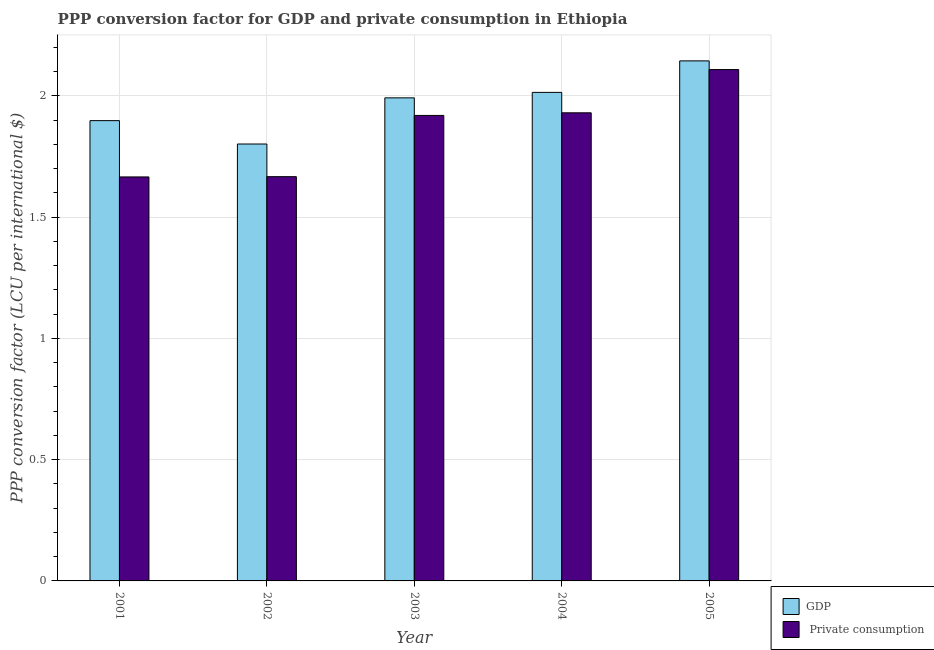How many different coloured bars are there?
Ensure brevity in your answer.  2. How many groups of bars are there?
Your response must be concise. 5. Are the number of bars per tick equal to the number of legend labels?
Ensure brevity in your answer.  Yes. Are the number of bars on each tick of the X-axis equal?
Make the answer very short. Yes. In how many cases, is the number of bars for a given year not equal to the number of legend labels?
Your response must be concise. 0. What is the ppp conversion factor for gdp in 2003?
Your response must be concise. 1.99. Across all years, what is the maximum ppp conversion factor for private consumption?
Provide a short and direct response. 2.11. Across all years, what is the minimum ppp conversion factor for gdp?
Provide a short and direct response. 1.8. In which year was the ppp conversion factor for private consumption maximum?
Your answer should be very brief. 2005. What is the total ppp conversion factor for gdp in the graph?
Provide a short and direct response. 9.85. What is the difference between the ppp conversion factor for gdp in 2003 and that in 2004?
Make the answer very short. -0.02. What is the difference between the ppp conversion factor for gdp in 2003 and the ppp conversion factor for private consumption in 2004?
Your answer should be compact. -0.02. What is the average ppp conversion factor for gdp per year?
Provide a succinct answer. 1.97. In the year 2002, what is the difference between the ppp conversion factor for gdp and ppp conversion factor for private consumption?
Offer a very short reply. 0. What is the ratio of the ppp conversion factor for private consumption in 2002 to that in 2005?
Your response must be concise. 0.79. What is the difference between the highest and the second highest ppp conversion factor for gdp?
Your answer should be very brief. 0.13. What is the difference between the highest and the lowest ppp conversion factor for gdp?
Offer a very short reply. 0.34. In how many years, is the ppp conversion factor for gdp greater than the average ppp conversion factor for gdp taken over all years?
Your answer should be very brief. 3. Is the sum of the ppp conversion factor for private consumption in 2004 and 2005 greater than the maximum ppp conversion factor for gdp across all years?
Offer a terse response. Yes. What does the 1st bar from the left in 2005 represents?
Keep it short and to the point. GDP. What does the 1st bar from the right in 2002 represents?
Provide a short and direct response.  Private consumption. Are all the bars in the graph horizontal?
Provide a short and direct response. No. What is the difference between two consecutive major ticks on the Y-axis?
Keep it short and to the point. 0.5. Does the graph contain any zero values?
Keep it short and to the point. No. How many legend labels are there?
Your answer should be very brief. 2. How are the legend labels stacked?
Make the answer very short. Vertical. What is the title of the graph?
Make the answer very short. PPP conversion factor for GDP and private consumption in Ethiopia. What is the label or title of the X-axis?
Provide a succinct answer. Year. What is the label or title of the Y-axis?
Your answer should be very brief. PPP conversion factor (LCU per international $). What is the PPP conversion factor (LCU per international $) in GDP in 2001?
Your answer should be compact. 1.9. What is the PPP conversion factor (LCU per international $) of  Private consumption in 2001?
Provide a succinct answer. 1.67. What is the PPP conversion factor (LCU per international $) in GDP in 2002?
Give a very brief answer. 1.8. What is the PPP conversion factor (LCU per international $) in  Private consumption in 2002?
Provide a succinct answer. 1.67. What is the PPP conversion factor (LCU per international $) in GDP in 2003?
Give a very brief answer. 1.99. What is the PPP conversion factor (LCU per international $) of  Private consumption in 2003?
Provide a short and direct response. 1.92. What is the PPP conversion factor (LCU per international $) in GDP in 2004?
Provide a short and direct response. 2.01. What is the PPP conversion factor (LCU per international $) in  Private consumption in 2004?
Offer a very short reply. 1.93. What is the PPP conversion factor (LCU per international $) in GDP in 2005?
Offer a very short reply. 2.14. What is the PPP conversion factor (LCU per international $) of  Private consumption in 2005?
Provide a short and direct response. 2.11. Across all years, what is the maximum PPP conversion factor (LCU per international $) of GDP?
Give a very brief answer. 2.14. Across all years, what is the maximum PPP conversion factor (LCU per international $) of  Private consumption?
Ensure brevity in your answer.  2.11. Across all years, what is the minimum PPP conversion factor (LCU per international $) in GDP?
Offer a terse response. 1.8. Across all years, what is the minimum PPP conversion factor (LCU per international $) of  Private consumption?
Ensure brevity in your answer.  1.67. What is the total PPP conversion factor (LCU per international $) in GDP in the graph?
Give a very brief answer. 9.85. What is the total PPP conversion factor (LCU per international $) of  Private consumption in the graph?
Provide a short and direct response. 9.29. What is the difference between the PPP conversion factor (LCU per international $) in GDP in 2001 and that in 2002?
Provide a succinct answer. 0.1. What is the difference between the PPP conversion factor (LCU per international $) of  Private consumption in 2001 and that in 2002?
Keep it short and to the point. -0. What is the difference between the PPP conversion factor (LCU per international $) in GDP in 2001 and that in 2003?
Make the answer very short. -0.09. What is the difference between the PPP conversion factor (LCU per international $) in  Private consumption in 2001 and that in 2003?
Give a very brief answer. -0.25. What is the difference between the PPP conversion factor (LCU per international $) of GDP in 2001 and that in 2004?
Your answer should be compact. -0.12. What is the difference between the PPP conversion factor (LCU per international $) in  Private consumption in 2001 and that in 2004?
Provide a succinct answer. -0.26. What is the difference between the PPP conversion factor (LCU per international $) in GDP in 2001 and that in 2005?
Your response must be concise. -0.25. What is the difference between the PPP conversion factor (LCU per international $) of  Private consumption in 2001 and that in 2005?
Your response must be concise. -0.44. What is the difference between the PPP conversion factor (LCU per international $) of GDP in 2002 and that in 2003?
Keep it short and to the point. -0.19. What is the difference between the PPP conversion factor (LCU per international $) of  Private consumption in 2002 and that in 2003?
Offer a terse response. -0.25. What is the difference between the PPP conversion factor (LCU per international $) in GDP in 2002 and that in 2004?
Offer a terse response. -0.21. What is the difference between the PPP conversion factor (LCU per international $) of  Private consumption in 2002 and that in 2004?
Your answer should be compact. -0.26. What is the difference between the PPP conversion factor (LCU per international $) in GDP in 2002 and that in 2005?
Offer a terse response. -0.34. What is the difference between the PPP conversion factor (LCU per international $) of  Private consumption in 2002 and that in 2005?
Offer a very short reply. -0.44. What is the difference between the PPP conversion factor (LCU per international $) in GDP in 2003 and that in 2004?
Make the answer very short. -0.02. What is the difference between the PPP conversion factor (LCU per international $) of  Private consumption in 2003 and that in 2004?
Your answer should be very brief. -0.01. What is the difference between the PPP conversion factor (LCU per international $) of GDP in 2003 and that in 2005?
Your response must be concise. -0.15. What is the difference between the PPP conversion factor (LCU per international $) in  Private consumption in 2003 and that in 2005?
Your answer should be compact. -0.19. What is the difference between the PPP conversion factor (LCU per international $) in GDP in 2004 and that in 2005?
Your response must be concise. -0.13. What is the difference between the PPP conversion factor (LCU per international $) of  Private consumption in 2004 and that in 2005?
Give a very brief answer. -0.18. What is the difference between the PPP conversion factor (LCU per international $) of GDP in 2001 and the PPP conversion factor (LCU per international $) of  Private consumption in 2002?
Offer a very short reply. 0.23. What is the difference between the PPP conversion factor (LCU per international $) in GDP in 2001 and the PPP conversion factor (LCU per international $) in  Private consumption in 2003?
Your answer should be compact. -0.02. What is the difference between the PPP conversion factor (LCU per international $) of GDP in 2001 and the PPP conversion factor (LCU per international $) of  Private consumption in 2004?
Provide a succinct answer. -0.03. What is the difference between the PPP conversion factor (LCU per international $) in GDP in 2001 and the PPP conversion factor (LCU per international $) in  Private consumption in 2005?
Provide a succinct answer. -0.21. What is the difference between the PPP conversion factor (LCU per international $) in GDP in 2002 and the PPP conversion factor (LCU per international $) in  Private consumption in 2003?
Offer a very short reply. -0.12. What is the difference between the PPP conversion factor (LCU per international $) of GDP in 2002 and the PPP conversion factor (LCU per international $) of  Private consumption in 2004?
Your answer should be compact. -0.13. What is the difference between the PPP conversion factor (LCU per international $) of GDP in 2002 and the PPP conversion factor (LCU per international $) of  Private consumption in 2005?
Offer a terse response. -0.31. What is the difference between the PPP conversion factor (LCU per international $) in GDP in 2003 and the PPP conversion factor (LCU per international $) in  Private consumption in 2004?
Your response must be concise. 0.06. What is the difference between the PPP conversion factor (LCU per international $) of GDP in 2003 and the PPP conversion factor (LCU per international $) of  Private consumption in 2005?
Ensure brevity in your answer.  -0.12. What is the difference between the PPP conversion factor (LCU per international $) of GDP in 2004 and the PPP conversion factor (LCU per international $) of  Private consumption in 2005?
Provide a succinct answer. -0.09. What is the average PPP conversion factor (LCU per international $) of GDP per year?
Offer a terse response. 1.97. What is the average PPP conversion factor (LCU per international $) of  Private consumption per year?
Offer a very short reply. 1.86. In the year 2001, what is the difference between the PPP conversion factor (LCU per international $) in GDP and PPP conversion factor (LCU per international $) in  Private consumption?
Provide a short and direct response. 0.23. In the year 2002, what is the difference between the PPP conversion factor (LCU per international $) of GDP and PPP conversion factor (LCU per international $) of  Private consumption?
Provide a succinct answer. 0.13. In the year 2003, what is the difference between the PPP conversion factor (LCU per international $) in GDP and PPP conversion factor (LCU per international $) in  Private consumption?
Give a very brief answer. 0.07. In the year 2004, what is the difference between the PPP conversion factor (LCU per international $) in GDP and PPP conversion factor (LCU per international $) in  Private consumption?
Your response must be concise. 0.08. In the year 2005, what is the difference between the PPP conversion factor (LCU per international $) in GDP and PPP conversion factor (LCU per international $) in  Private consumption?
Offer a very short reply. 0.04. What is the ratio of the PPP conversion factor (LCU per international $) in GDP in 2001 to that in 2002?
Offer a very short reply. 1.05. What is the ratio of the PPP conversion factor (LCU per international $) of GDP in 2001 to that in 2003?
Your response must be concise. 0.95. What is the ratio of the PPP conversion factor (LCU per international $) in  Private consumption in 2001 to that in 2003?
Provide a succinct answer. 0.87. What is the ratio of the PPP conversion factor (LCU per international $) of GDP in 2001 to that in 2004?
Provide a short and direct response. 0.94. What is the ratio of the PPP conversion factor (LCU per international $) in  Private consumption in 2001 to that in 2004?
Give a very brief answer. 0.86. What is the ratio of the PPP conversion factor (LCU per international $) of GDP in 2001 to that in 2005?
Keep it short and to the point. 0.89. What is the ratio of the PPP conversion factor (LCU per international $) in  Private consumption in 2001 to that in 2005?
Provide a short and direct response. 0.79. What is the ratio of the PPP conversion factor (LCU per international $) of GDP in 2002 to that in 2003?
Provide a short and direct response. 0.9. What is the ratio of the PPP conversion factor (LCU per international $) of  Private consumption in 2002 to that in 2003?
Ensure brevity in your answer.  0.87. What is the ratio of the PPP conversion factor (LCU per international $) in GDP in 2002 to that in 2004?
Your response must be concise. 0.89. What is the ratio of the PPP conversion factor (LCU per international $) of  Private consumption in 2002 to that in 2004?
Make the answer very short. 0.86. What is the ratio of the PPP conversion factor (LCU per international $) of GDP in 2002 to that in 2005?
Your response must be concise. 0.84. What is the ratio of the PPP conversion factor (LCU per international $) of  Private consumption in 2002 to that in 2005?
Give a very brief answer. 0.79. What is the ratio of the PPP conversion factor (LCU per international $) of GDP in 2003 to that in 2005?
Your answer should be very brief. 0.93. What is the ratio of the PPP conversion factor (LCU per international $) of  Private consumption in 2003 to that in 2005?
Keep it short and to the point. 0.91. What is the ratio of the PPP conversion factor (LCU per international $) of GDP in 2004 to that in 2005?
Offer a very short reply. 0.94. What is the ratio of the PPP conversion factor (LCU per international $) in  Private consumption in 2004 to that in 2005?
Provide a short and direct response. 0.92. What is the difference between the highest and the second highest PPP conversion factor (LCU per international $) in GDP?
Provide a short and direct response. 0.13. What is the difference between the highest and the second highest PPP conversion factor (LCU per international $) of  Private consumption?
Offer a terse response. 0.18. What is the difference between the highest and the lowest PPP conversion factor (LCU per international $) of GDP?
Your answer should be very brief. 0.34. What is the difference between the highest and the lowest PPP conversion factor (LCU per international $) in  Private consumption?
Keep it short and to the point. 0.44. 